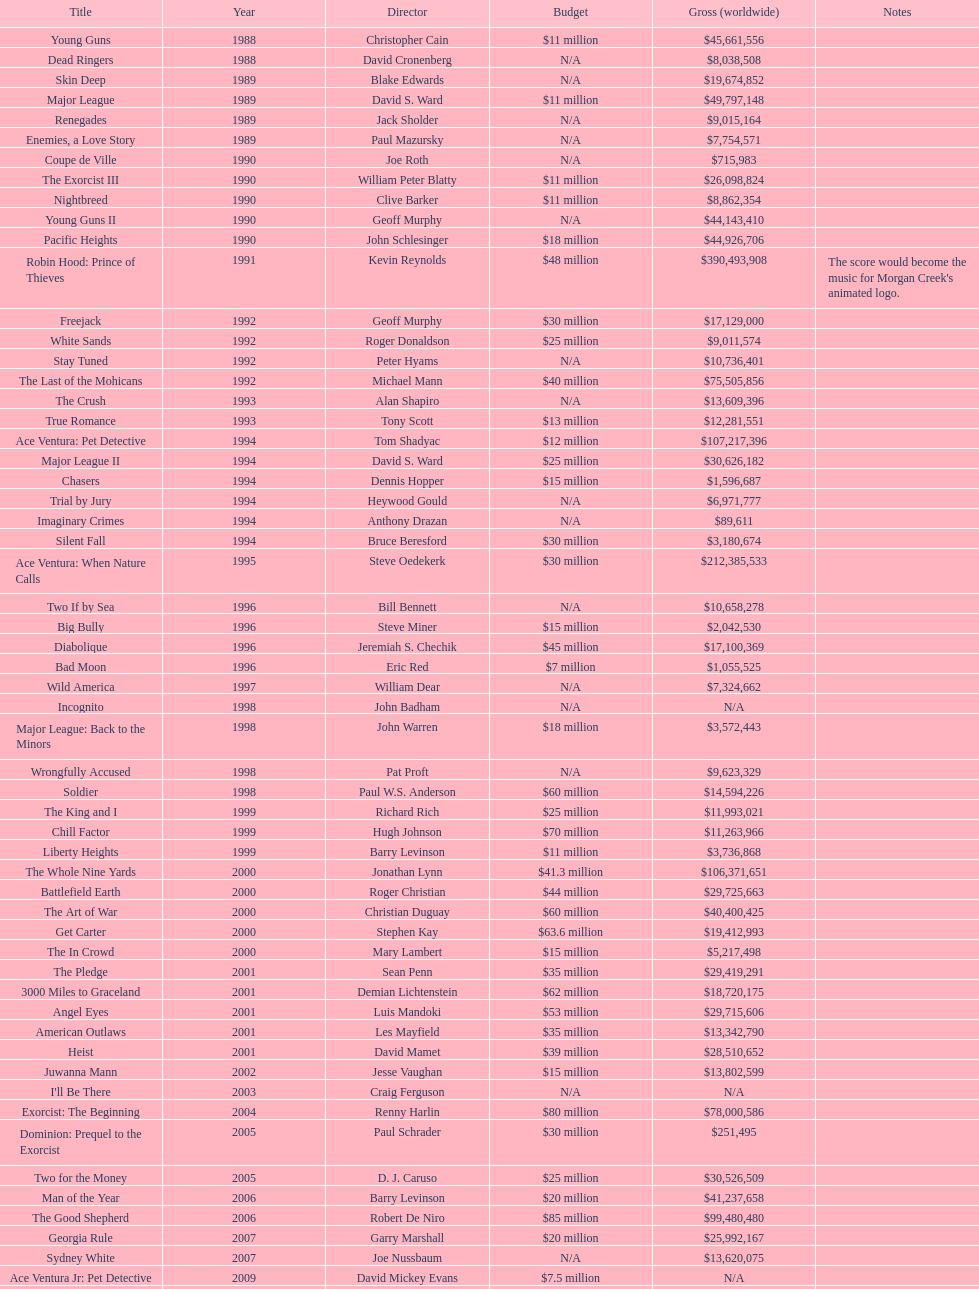After young guns, what was the next movie with the exact same budget? Major League. 